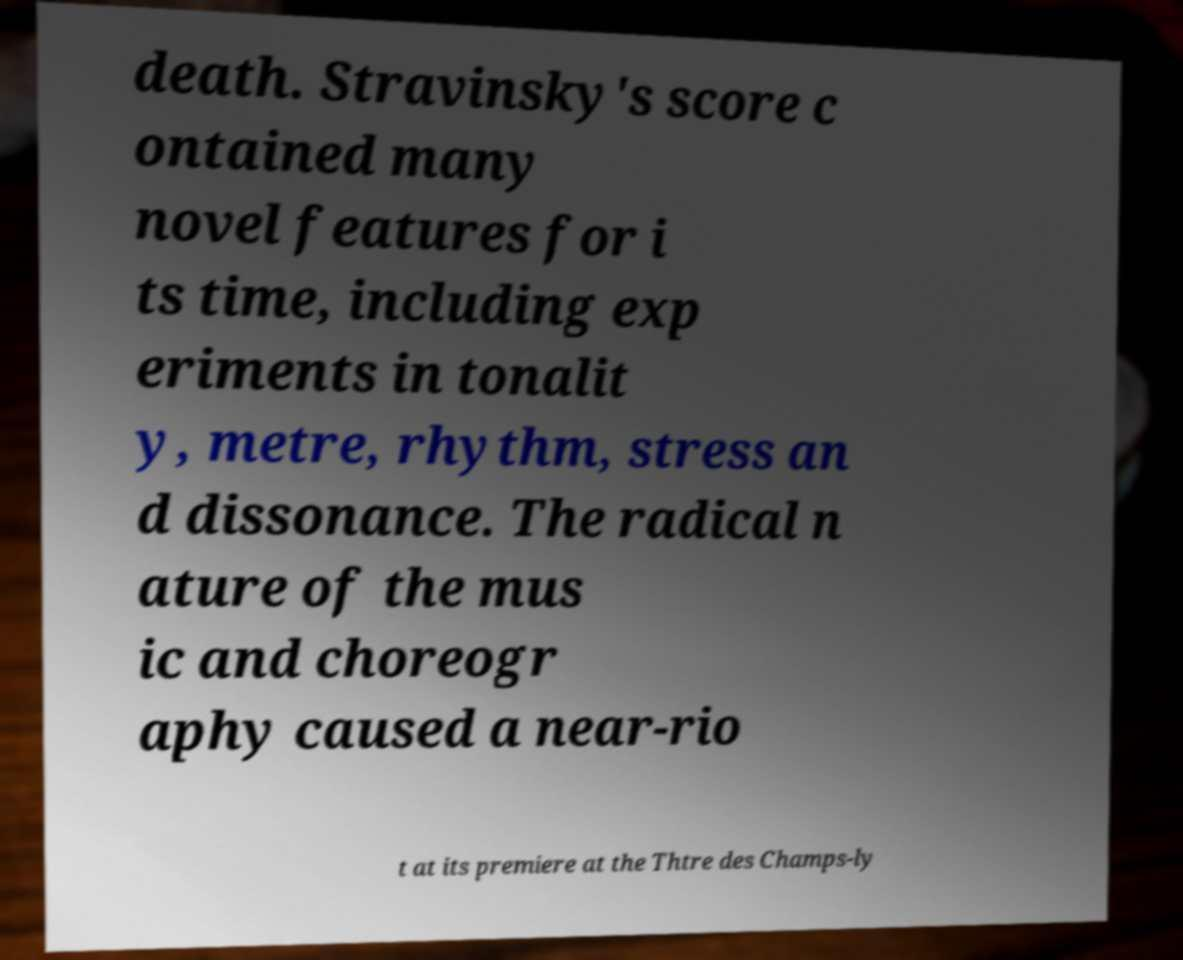Could you assist in decoding the text presented in this image and type it out clearly? death. Stravinsky's score c ontained many novel features for i ts time, including exp eriments in tonalit y, metre, rhythm, stress an d dissonance. The radical n ature of the mus ic and choreogr aphy caused a near-rio t at its premiere at the Thtre des Champs-ly 